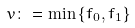<formula> <loc_0><loc_0><loc_500><loc_500>v \colon = \min \left \{ f _ { 0 } , f _ { 1 } \right \}</formula> 